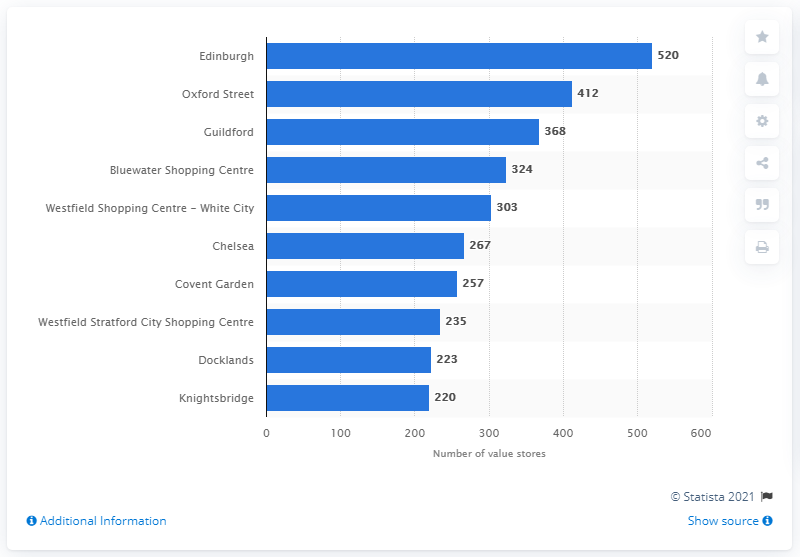Draw attention to some important aspects in this diagram. According to recent data, Edinburgh, the capital city of Scotland, boasts the highest number of luxury retail stores among all cities in the United Kingdom. 